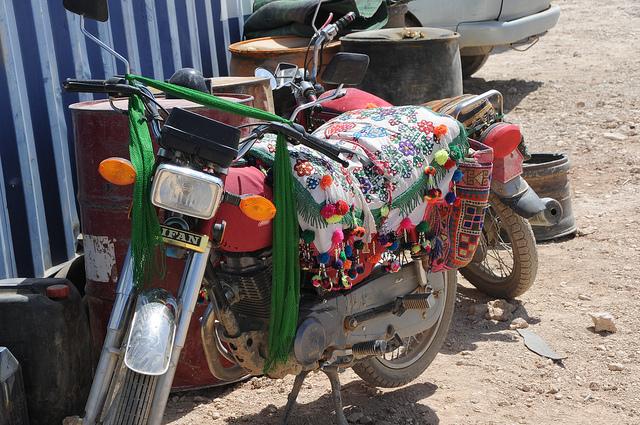How many wheels does this bike have?
Concise answer only. 2. What color is the fabric on the handles?
Answer briefly. Green. Is there dirt on the ground?
Short answer required. Yes. 